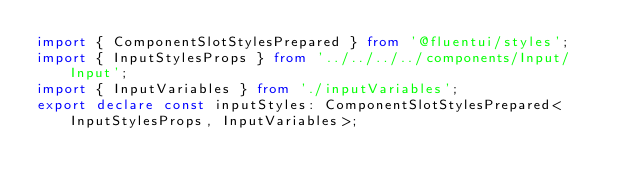<code> <loc_0><loc_0><loc_500><loc_500><_TypeScript_>import { ComponentSlotStylesPrepared } from '@fluentui/styles';
import { InputStylesProps } from '../../../../components/Input/Input';
import { InputVariables } from './inputVariables';
export declare const inputStyles: ComponentSlotStylesPrepared<InputStylesProps, InputVariables>;
</code> 